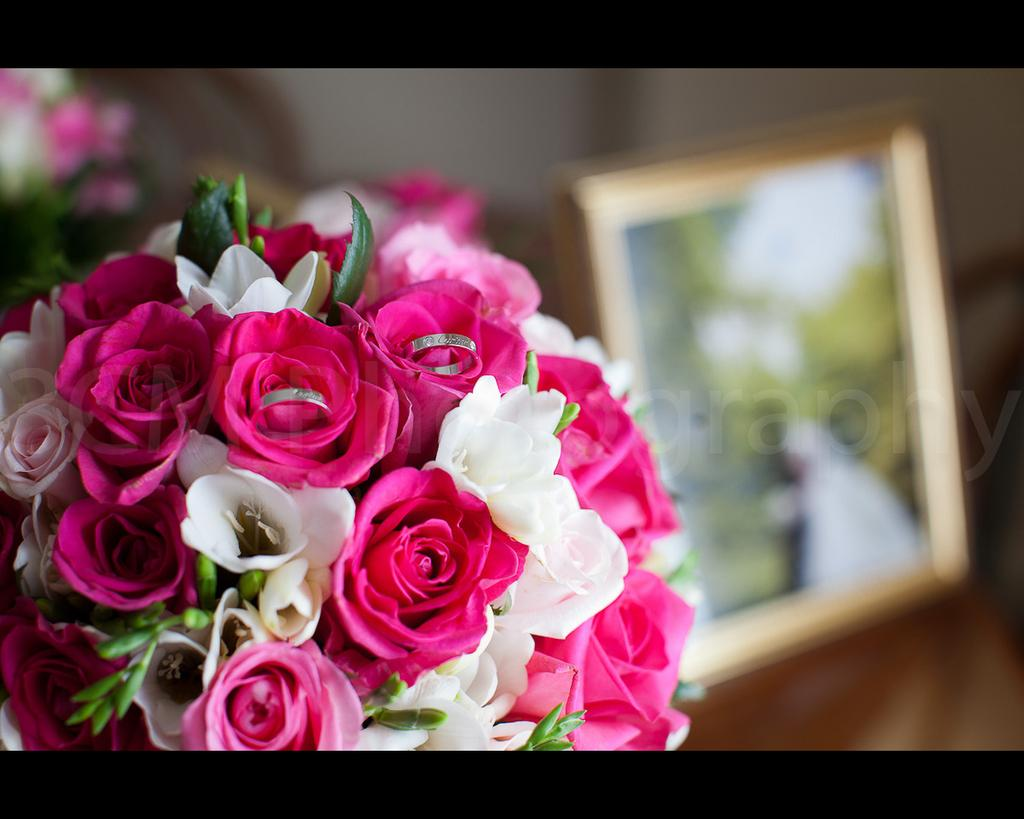What is the main subject of the image? There is a flower bouquet in the image. Are there any other objects visible in the image? Yes, there is a photo frame in the image. Can you describe the background of the image? The background of the image is blurred. What type of sock is being used to hold the flowers in the image? There is no sock present in the image, and the flowers are not being held by any sock. 